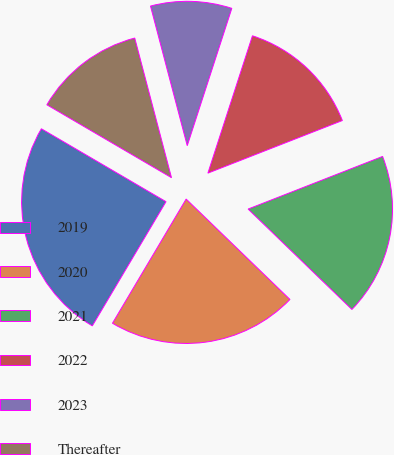Convert chart. <chart><loc_0><loc_0><loc_500><loc_500><pie_chart><fcel>2019<fcel>2020<fcel>2021<fcel>2022<fcel>2023<fcel>Thereafter<nl><fcel>24.9%<fcel>21.29%<fcel>18.17%<fcel>14.07%<fcel>9.09%<fcel>12.48%<nl></chart> 